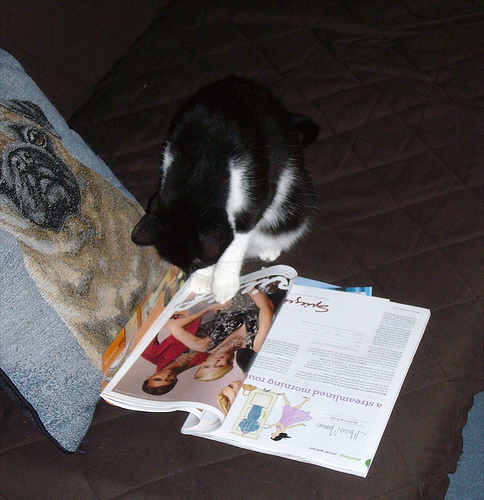<image>
Can you confirm if the cat is above the magazine? Yes. The cat is positioned above the magazine in the vertical space, higher up in the scene. 